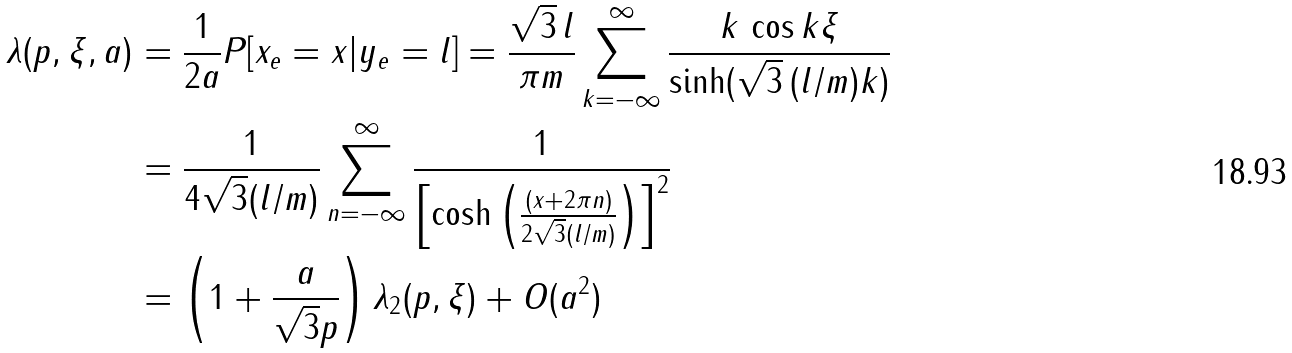Convert formula to latex. <formula><loc_0><loc_0><loc_500><loc_500>\lambda ( p , \xi , a ) & = \frac { 1 } { 2 a } P [ x _ { e } = x | y _ { e } = l ] = \frac { \sqrt { 3 } \, l } { \pi m } \sum _ { k = - \infty } ^ { \infty } \frac { k \, \cos k \xi } { \sinh ( \sqrt { 3 } \, ( l / m ) k ) } \\ & = \frac { 1 } { 4 \sqrt { 3 } ( l / m ) } \sum _ { n = - \infty } ^ { \infty } \frac { 1 } { \left [ \cosh \left ( \frac { ( x + 2 \pi n ) } { 2 \sqrt { 3 } ( l / m ) } \right ) \right ] ^ { 2 } } \\ & = \left ( 1 + \frac { a } { \sqrt { 3 } p } \right ) \lambda _ { 2 } ( p , \xi ) + O ( a ^ { 2 } )</formula> 